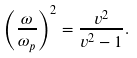<formula> <loc_0><loc_0><loc_500><loc_500>\left ( \frac { \omega } { \omega _ { p } } \right ) ^ { 2 } = \frac { v ^ { 2 } } { v ^ { 2 } - 1 } .</formula> 